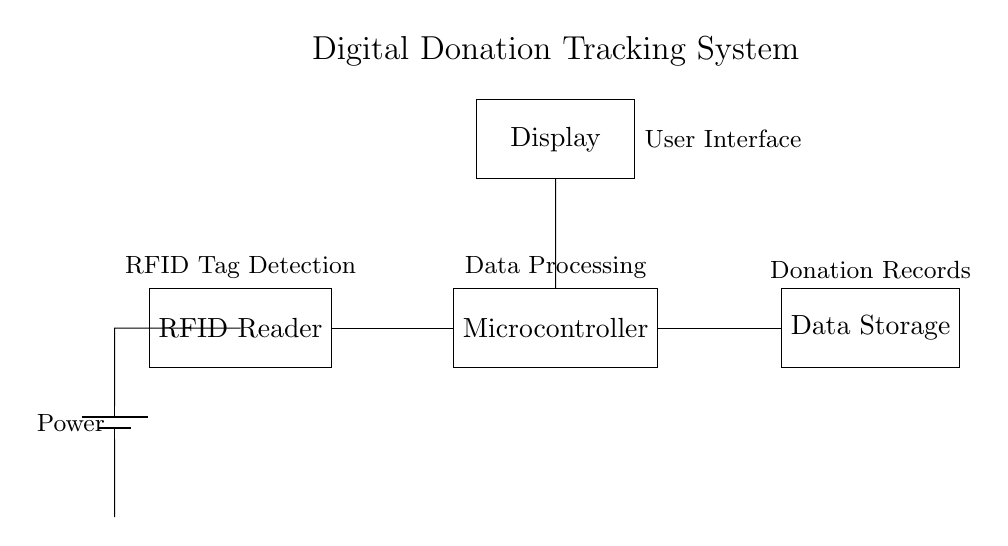What is the main function of the RFID reader in this circuit? The RFID reader is used to detect RFID tags, which enables tracking of donations. Its placement in the circuit shows that it interacts with the microcontroller for further data processing.
Answer: RFID tag detection What component processes the data from the RFID reader? The microcontroller is responsible for processing the data received from the RFID reader. Its central position in the circuit diagram indicates it handles the communication between the RFID reader, data storage, and display components.
Answer: Microcontroller What type of data is stored in the data storage unit? The data storage unit is designed to hold donation records. The label on the component in the circuit specifically indicates that it retains information related to the donations tracked by the system.
Answer: Donation records How many main components are in the circuit? There are four main components visible in the circuit: RFID reader, microcontroller, data storage, and display. Counting each component shown in the diagram leads to this total.
Answer: Four Where does the power supply connect in the circuit? The power supply connects to the RFID reader, indicating that it provides the necessary voltage to this component. The diagram shows a direct connection from the battery to the RFID reader, confirming its power source.
Answer: RFID reader What is the purpose of the display in this system? The display serves as the user interface, allowing users to view information related to the donations processed by the system. Its connection to the microcontroller illustrates its role in providing processed data outputs.
Answer: User interface 